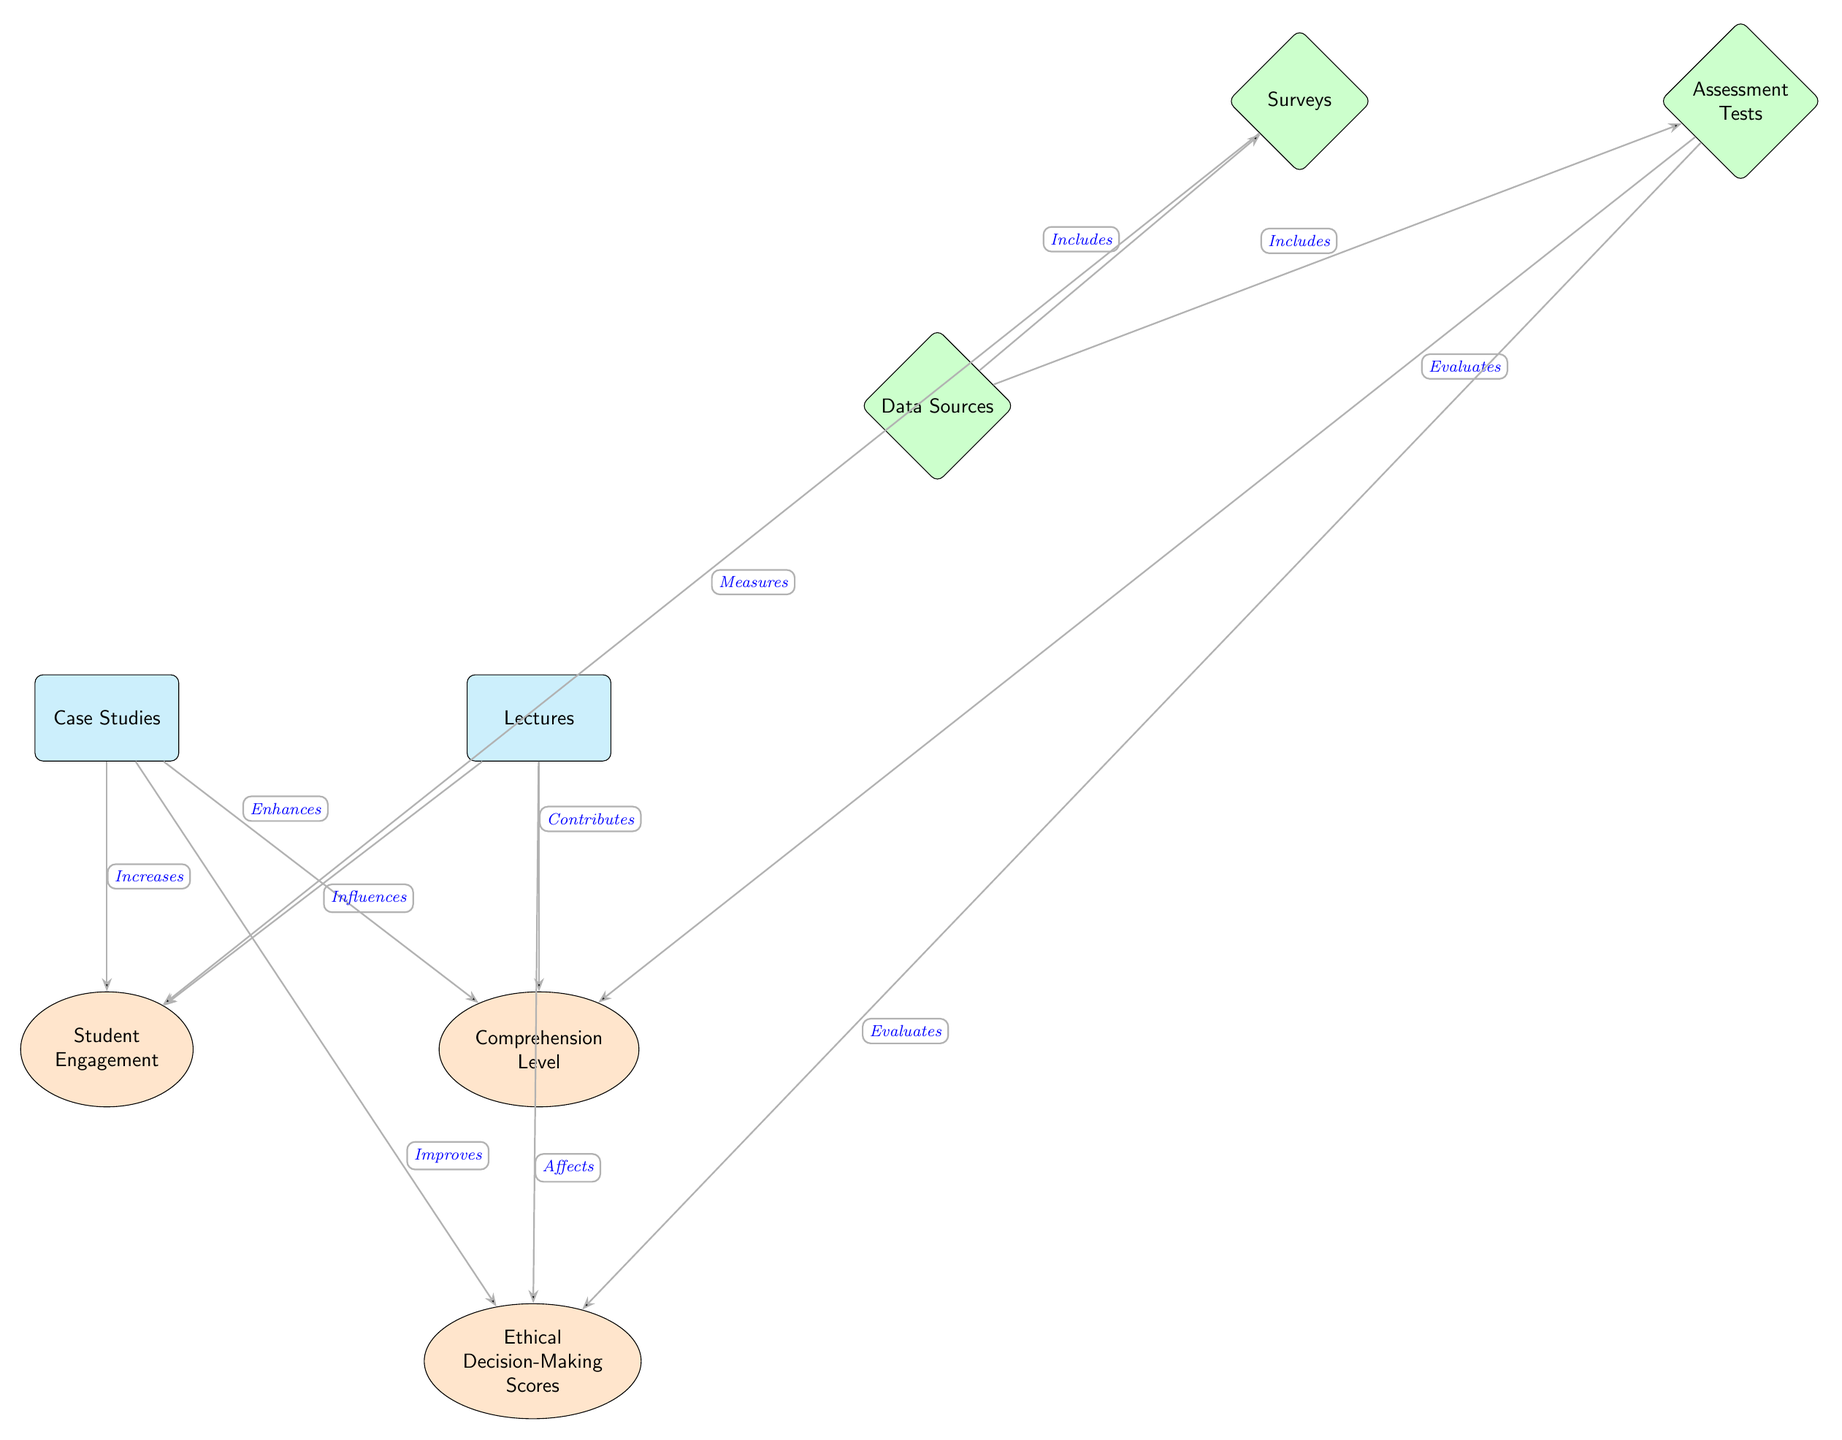What are the two teaching methods shown in the diagram? The diagram lists "Case Studies" and "Lectures" as the two teaching methods at the top.
Answer: Case Studies, Lectures Which outcome is directly associated with "Case Studies"? The diagram indicates that "Case Studies" enhances "Comprehension Level," as shown by the connecting edge labeled with "Enhances."
Answer: Comprehension Level How does "Lectures" influence "Student Engagement"? The diagram shows an edge connecting "Lectures" to "Student Engagement," labeled "Influences," indicating that lectures have an impact on student engagement.
Answer: Influences What type of data sources are mentioned in the diagram? The diagram includes "Surveys" and "Assessment Tests" as the two types of data sources, linked above "Data Sources."
Answer: Surveys, Assessment Tests Which teaching method has a direct connection to improving ethical decision-making scores? The diagram specifically states that "Case Studies" improves "Ethical Decision-Making Scores," indicated by the edge labeled "Improves."
Answer: Case Studies What metrics are used to evaluate "Comprehension Level"? According to the diagram, "Assessment Tests" are indicated as the measure for evaluating "Comprehension Level," reflecting a direct connection shown with the edge labeled "Evaluates."
Answer: Assessment Tests Which outcome is influenced by both teaching methods? The diagram illustrates that both "Case Studies" and "Lectures" influence "Student Engagement," indicated by separate arrows pointing towards that outcome.
Answer: Student Engagement How many total outcomes are represented in the diagram? There are three outcomes in the diagram: "Student Engagement," "Comprehension Level," and "Ethical Decision-Making Scores," which can be counted from the nodes below the teaching methods.
Answer: Three What connects the "Data Sources" to the "Surveys"? The edge labeled "Includes" connects "Data Sources" to "Surveys," which identifies that surveys are part of the data sources used in the analysis.
Answer: Includes 